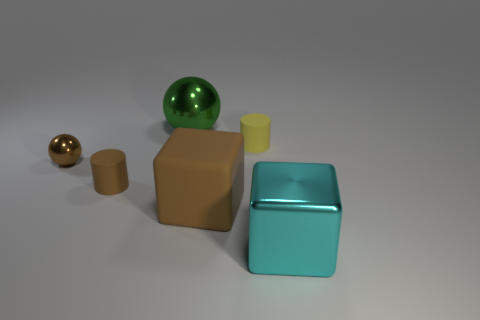Add 3 small rubber objects. How many objects exist? 9 Subtract all spheres. How many objects are left? 4 Subtract all tiny brown rubber cylinders. Subtract all tiny brown metallic balls. How many objects are left? 4 Add 4 tiny shiny objects. How many tiny shiny objects are left? 5 Add 3 brown rubber balls. How many brown rubber balls exist? 3 Subtract 0 red balls. How many objects are left? 6 